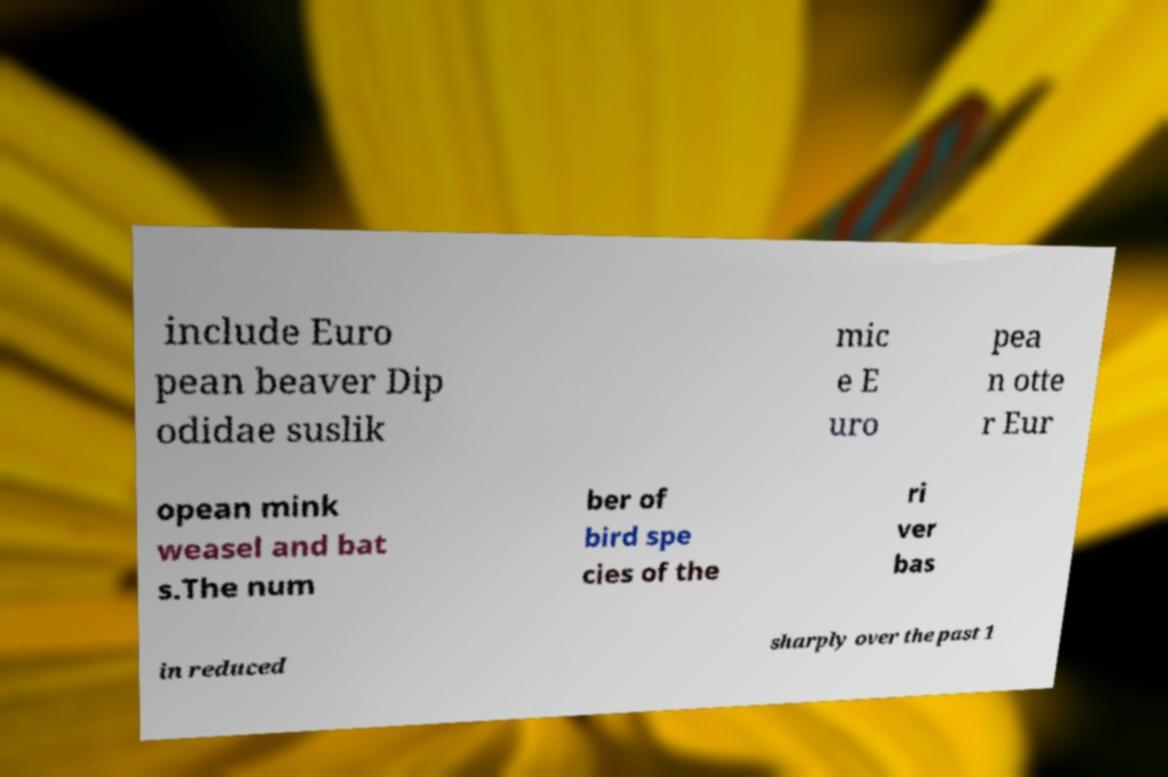Can you read and provide the text displayed in the image?This photo seems to have some interesting text. Can you extract and type it out for me? include Euro pean beaver Dip odidae suslik mic e E uro pea n otte r Eur opean mink weasel and bat s.The num ber of bird spe cies of the ri ver bas in reduced sharply over the past 1 